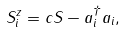<formula> <loc_0><loc_0><loc_500><loc_500>S ^ { z } _ { i } = c S - a ^ { \dag } _ { i } a _ { i } ,</formula> 